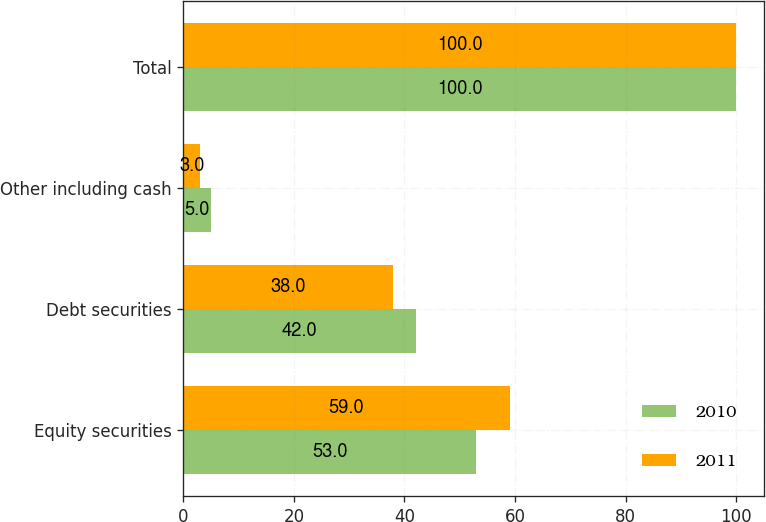<chart> <loc_0><loc_0><loc_500><loc_500><stacked_bar_chart><ecel><fcel>Equity securities<fcel>Debt securities<fcel>Other including cash<fcel>Total<nl><fcel>2010<fcel>53<fcel>42<fcel>5<fcel>100<nl><fcel>2011<fcel>59<fcel>38<fcel>3<fcel>100<nl></chart> 